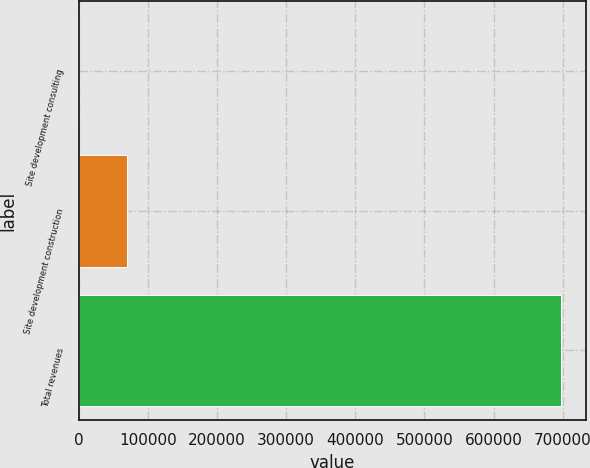Convert chart. <chart><loc_0><loc_0><loc_500><loc_500><bar_chart><fcel>Site development consulting<fcel>Site development construction<fcel>Total revenues<nl><fcel>2.5<fcel>69819.2<fcel>698170<nl></chart> 